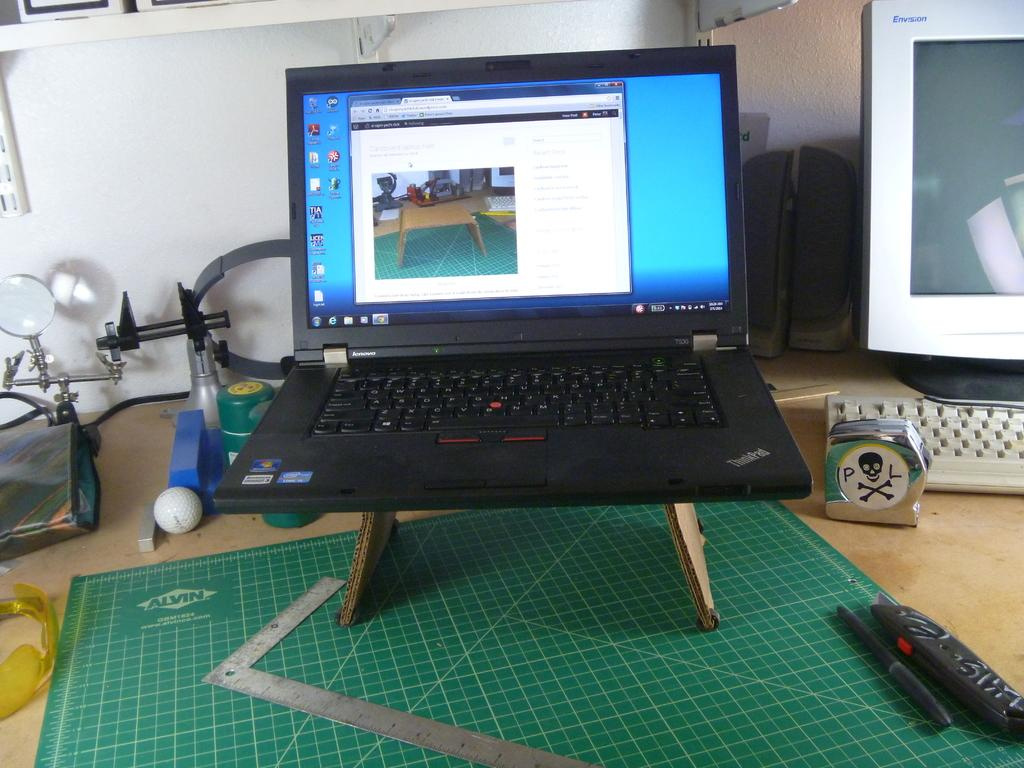<image>
Render a clear and concise summary of the photo. A laptop with a model number T530 on it and a Windows sticker. 